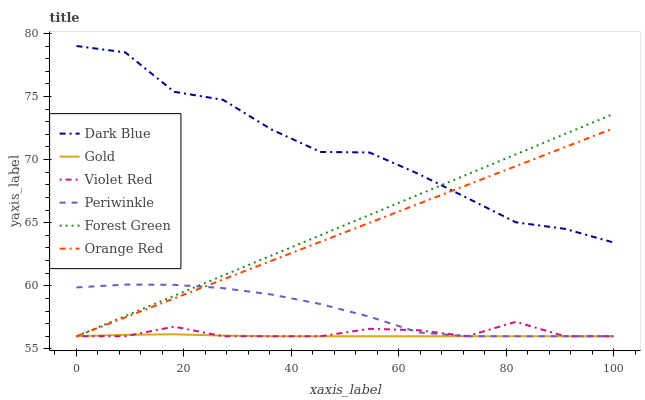Does Gold have the minimum area under the curve?
Answer yes or no. Yes. Does Dark Blue have the maximum area under the curve?
Answer yes or no. Yes. Does Dark Blue have the minimum area under the curve?
Answer yes or no. No. Does Gold have the maximum area under the curve?
Answer yes or no. No. Is Forest Green the smoothest?
Answer yes or no. Yes. Is Dark Blue the roughest?
Answer yes or no. Yes. Is Gold the smoothest?
Answer yes or no. No. Is Gold the roughest?
Answer yes or no. No. Does Violet Red have the lowest value?
Answer yes or no. Yes. Does Dark Blue have the lowest value?
Answer yes or no. No. Does Dark Blue have the highest value?
Answer yes or no. Yes. Does Gold have the highest value?
Answer yes or no. No. Is Violet Red less than Dark Blue?
Answer yes or no. Yes. Is Dark Blue greater than Gold?
Answer yes or no. Yes. Does Gold intersect Periwinkle?
Answer yes or no. Yes. Is Gold less than Periwinkle?
Answer yes or no. No. Is Gold greater than Periwinkle?
Answer yes or no. No. Does Violet Red intersect Dark Blue?
Answer yes or no. No. 